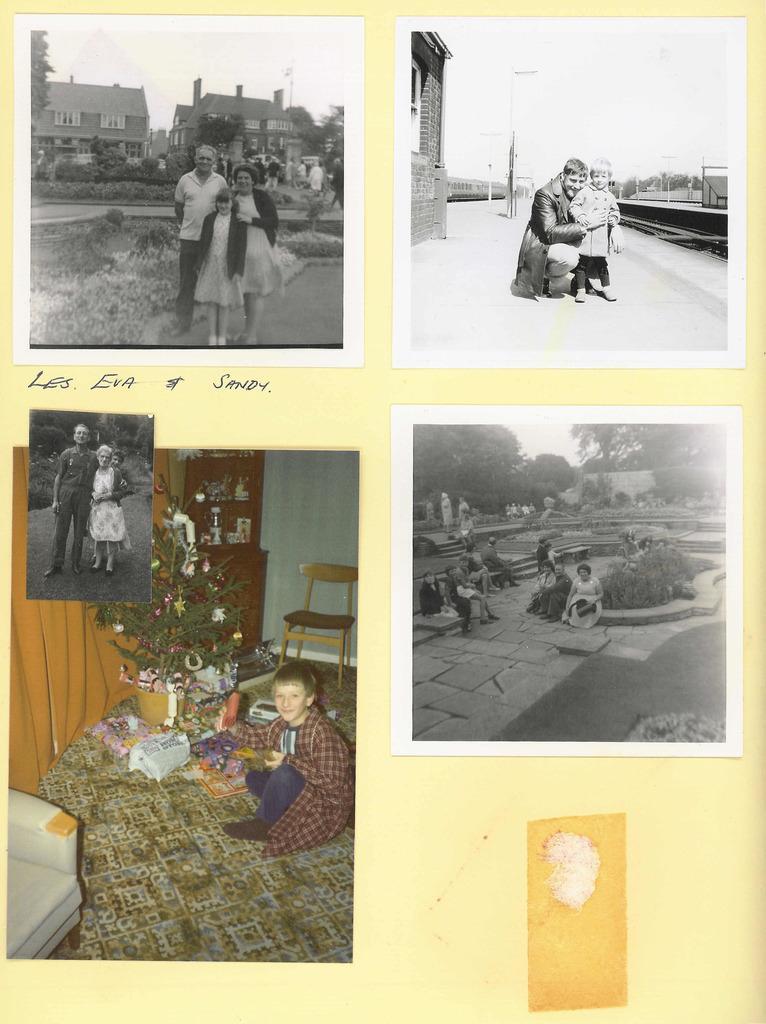Could you give a brief overview of what you see in this image? I see this is a collage image and I see number of people and I see a chair over here and I see the path in these 3 pics and I see the plants and trees and I see number of buildings and I see the sky. 